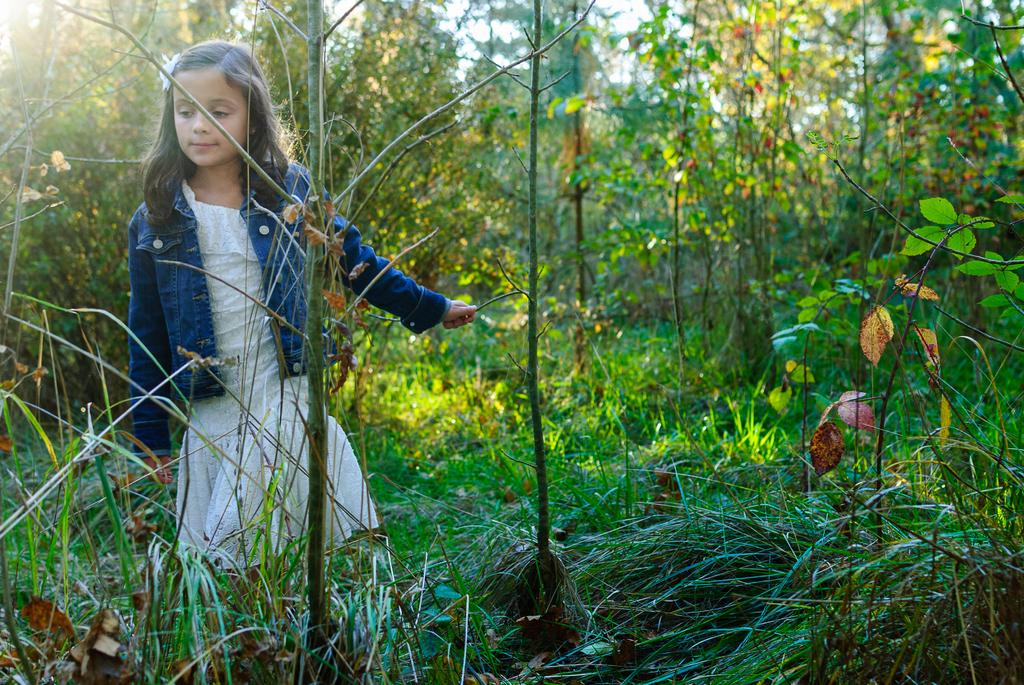Who is the main subject in the image? There is a girl in the image. What is the girl standing on? The girl is standing on land with grass and plants. What can be seen in the background of the image? There are trees in the background of the image. What is the girl wearing? The girl is wearing a jacket. What type of horse can be seen grazing in the background of the image? There is no horse present in the image; the background features trees. 